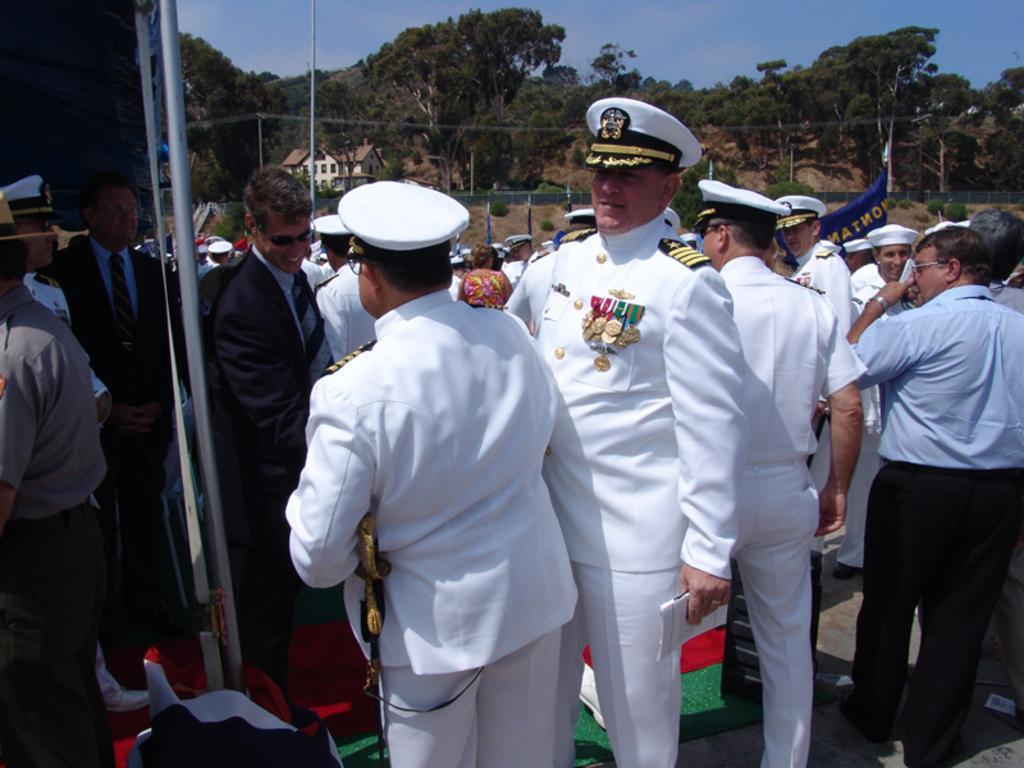In one or two sentences, can you explain what this image depicts? In this image I can see group of people standing. In front the person is wearing white color dress. In the background I can see few houses, trees in green color and the sky is in blue color. 